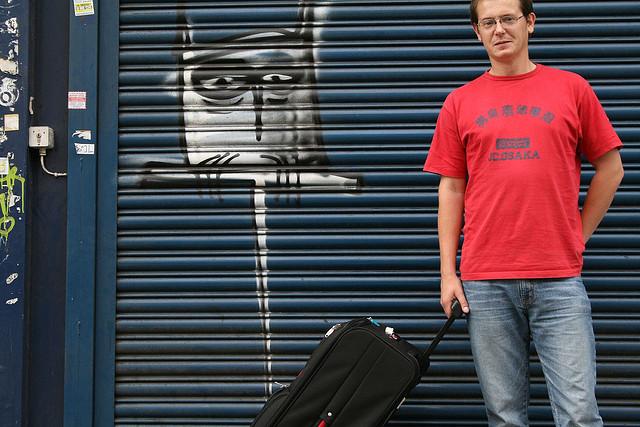What is the man holding?
Be succinct. Suitcase. Is the man carrying the suitcase?
Answer briefly. No. What is painted on the wall?
Concise answer only. Owl. 